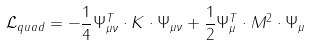<formula> <loc_0><loc_0><loc_500><loc_500>\mathcal { L } _ { q u a d } = - \frac { 1 } { 4 } \Psi _ { \mu \nu } ^ { T } \cdot K \cdot \Psi _ { \mu \nu } + \frac { 1 } { 2 } \Psi _ { \mu } ^ { T } \cdot M ^ { 2 } \cdot \Psi _ { \mu }</formula> 